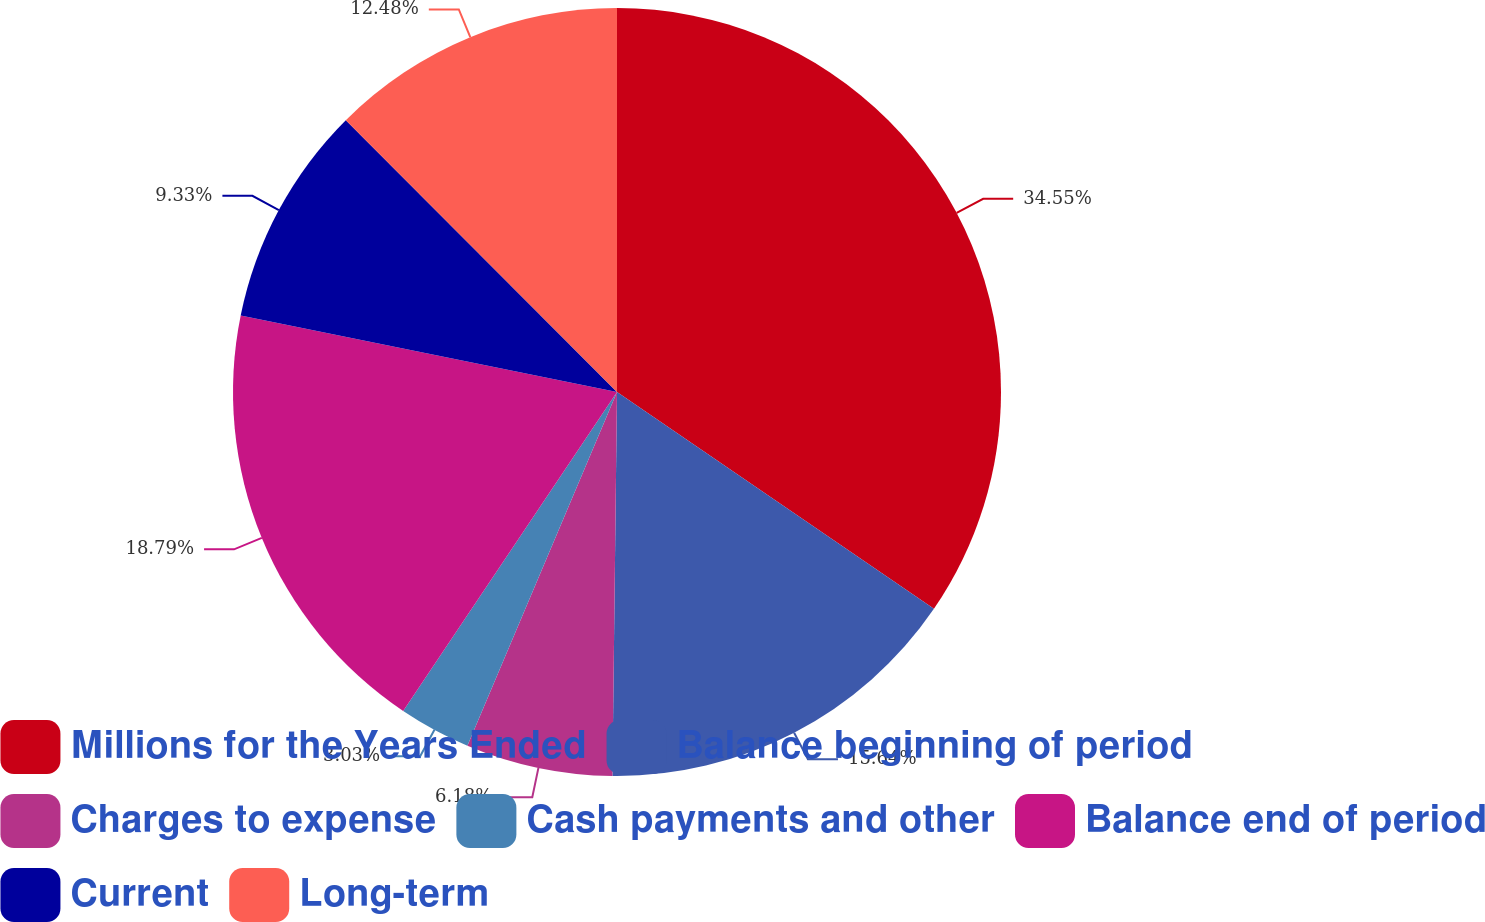<chart> <loc_0><loc_0><loc_500><loc_500><pie_chart><fcel>Millions for the Years Ended<fcel>Balance beginning of period<fcel>Charges to expense<fcel>Cash payments and other<fcel>Balance end of period<fcel>Current<fcel>Long-term<nl><fcel>34.55%<fcel>15.64%<fcel>6.18%<fcel>3.03%<fcel>18.79%<fcel>9.33%<fcel>12.48%<nl></chart> 